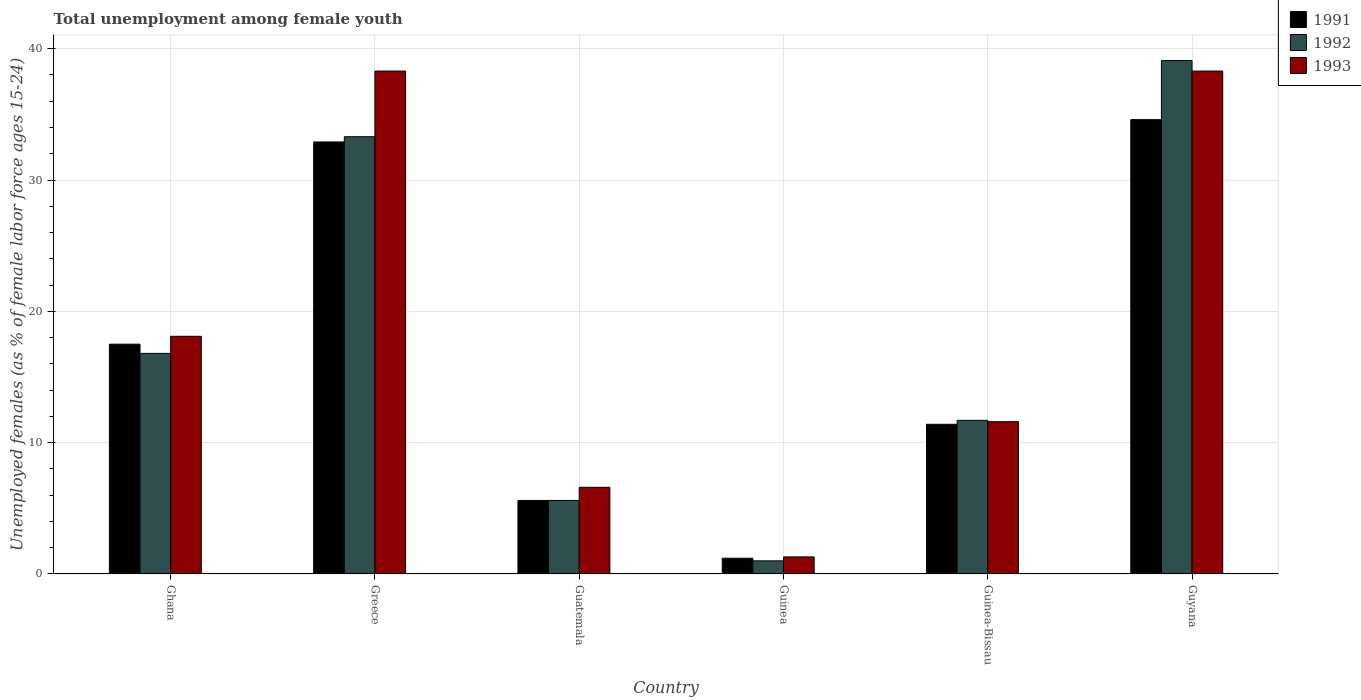How many different coloured bars are there?
Give a very brief answer. 3. Are the number of bars per tick equal to the number of legend labels?
Your answer should be compact. Yes. What is the label of the 4th group of bars from the left?
Offer a terse response. Guinea. In how many cases, is the number of bars for a given country not equal to the number of legend labels?
Give a very brief answer. 0. What is the percentage of unemployed females in in 1991 in Guatemala?
Give a very brief answer. 5.6. Across all countries, what is the maximum percentage of unemployed females in in 1992?
Make the answer very short. 39.1. In which country was the percentage of unemployed females in in 1991 maximum?
Your answer should be very brief. Guyana. In which country was the percentage of unemployed females in in 1992 minimum?
Your response must be concise. Guinea. What is the total percentage of unemployed females in in 1992 in the graph?
Your answer should be compact. 107.5. What is the difference between the percentage of unemployed females in in 1991 in Greece and that in Guatemala?
Offer a terse response. 27.3. What is the difference between the percentage of unemployed females in in 1993 in Guyana and the percentage of unemployed females in in 1992 in Guinea?
Your response must be concise. 37.3. What is the average percentage of unemployed females in in 1991 per country?
Ensure brevity in your answer.  17.2. What is the difference between the percentage of unemployed females in of/in 1991 and percentage of unemployed females in of/in 1992 in Greece?
Ensure brevity in your answer.  -0.4. In how many countries, is the percentage of unemployed females in in 1991 greater than 12 %?
Make the answer very short. 3. What is the ratio of the percentage of unemployed females in in 1992 in Greece to that in Guinea?
Your answer should be compact. 33.3. Is the percentage of unemployed females in in 1993 in Guinea less than that in Guinea-Bissau?
Keep it short and to the point. Yes. Is the difference between the percentage of unemployed females in in 1991 in Guatemala and Guyana greater than the difference between the percentage of unemployed females in in 1992 in Guatemala and Guyana?
Provide a short and direct response. Yes. What is the difference between the highest and the second highest percentage of unemployed females in in 1991?
Give a very brief answer. 15.4. What is the difference between the highest and the lowest percentage of unemployed females in in 1991?
Your answer should be compact. 33.4. In how many countries, is the percentage of unemployed females in in 1991 greater than the average percentage of unemployed females in in 1991 taken over all countries?
Make the answer very short. 3. Is it the case that in every country, the sum of the percentage of unemployed females in in 1993 and percentage of unemployed females in in 1991 is greater than the percentage of unemployed females in in 1992?
Offer a terse response. Yes. How many bars are there?
Offer a terse response. 18. Are all the bars in the graph horizontal?
Offer a very short reply. No. How many countries are there in the graph?
Ensure brevity in your answer.  6. Does the graph contain grids?
Make the answer very short. Yes. What is the title of the graph?
Ensure brevity in your answer.  Total unemployment among female youth. What is the label or title of the X-axis?
Keep it short and to the point. Country. What is the label or title of the Y-axis?
Offer a very short reply. Unemployed females (as % of female labor force ages 15-24). What is the Unemployed females (as % of female labor force ages 15-24) in 1991 in Ghana?
Your response must be concise. 17.5. What is the Unemployed females (as % of female labor force ages 15-24) of 1992 in Ghana?
Offer a very short reply. 16.8. What is the Unemployed females (as % of female labor force ages 15-24) of 1993 in Ghana?
Your answer should be very brief. 18.1. What is the Unemployed females (as % of female labor force ages 15-24) in 1991 in Greece?
Keep it short and to the point. 32.9. What is the Unemployed females (as % of female labor force ages 15-24) in 1992 in Greece?
Provide a succinct answer. 33.3. What is the Unemployed females (as % of female labor force ages 15-24) of 1993 in Greece?
Provide a succinct answer. 38.3. What is the Unemployed females (as % of female labor force ages 15-24) in 1991 in Guatemala?
Offer a terse response. 5.6. What is the Unemployed females (as % of female labor force ages 15-24) in 1992 in Guatemala?
Your answer should be very brief. 5.6. What is the Unemployed females (as % of female labor force ages 15-24) of 1993 in Guatemala?
Make the answer very short. 6.6. What is the Unemployed females (as % of female labor force ages 15-24) of 1991 in Guinea?
Offer a very short reply. 1.2. What is the Unemployed females (as % of female labor force ages 15-24) of 1993 in Guinea?
Provide a succinct answer. 1.3. What is the Unemployed females (as % of female labor force ages 15-24) in 1991 in Guinea-Bissau?
Offer a very short reply. 11.4. What is the Unemployed females (as % of female labor force ages 15-24) of 1992 in Guinea-Bissau?
Provide a short and direct response. 11.7. What is the Unemployed females (as % of female labor force ages 15-24) in 1993 in Guinea-Bissau?
Make the answer very short. 11.6. What is the Unemployed females (as % of female labor force ages 15-24) in 1991 in Guyana?
Make the answer very short. 34.6. What is the Unemployed females (as % of female labor force ages 15-24) of 1992 in Guyana?
Your answer should be compact. 39.1. What is the Unemployed females (as % of female labor force ages 15-24) of 1993 in Guyana?
Your answer should be very brief. 38.3. Across all countries, what is the maximum Unemployed females (as % of female labor force ages 15-24) in 1991?
Your answer should be very brief. 34.6. Across all countries, what is the maximum Unemployed females (as % of female labor force ages 15-24) in 1992?
Ensure brevity in your answer.  39.1. Across all countries, what is the maximum Unemployed females (as % of female labor force ages 15-24) of 1993?
Provide a short and direct response. 38.3. Across all countries, what is the minimum Unemployed females (as % of female labor force ages 15-24) in 1991?
Offer a very short reply. 1.2. Across all countries, what is the minimum Unemployed females (as % of female labor force ages 15-24) of 1992?
Provide a succinct answer. 1. Across all countries, what is the minimum Unemployed females (as % of female labor force ages 15-24) in 1993?
Make the answer very short. 1.3. What is the total Unemployed females (as % of female labor force ages 15-24) of 1991 in the graph?
Provide a short and direct response. 103.2. What is the total Unemployed females (as % of female labor force ages 15-24) in 1992 in the graph?
Your response must be concise. 107.5. What is the total Unemployed females (as % of female labor force ages 15-24) in 1993 in the graph?
Your response must be concise. 114.2. What is the difference between the Unemployed females (as % of female labor force ages 15-24) in 1991 in Ghana and that in Greece?
Make the answer very short. -15.4. What is the difference between the Unemployed females (as % of female labor force ages 15-24) of 1992 in Ghana and that in Greece?
Offer a very short reply. -16.5. What is the difference between the Unemployed females (as % of female labor force ages 15-24) in 1993 in Ghana and that in Greece?
Give a very brief answer. -20.2. What is the difference between the Unemployed females (as % of female labor force ages 15-24) of 1991 in Ghana and that in Guatemala?
Keep it short and to the point. 11.9. What is the difference between the Unemployed females (as % of female labor force ages 15-24) in 1992 in Ghana and that in Guatemala?
Offer a very short reply. 11.2. What is the difference between the Unemployed females (as % of female labor force ages 15-24) of 1991 in Ghana and that in Guyana?
Make the answer very short. -17.1. What is the difference between the Unemployed females (as % of female labor force ages 15-24) in 1992 in Ghana and that in Guyana?
Give a very brief answer. -22.3. What is the difference between the Unemployed females (as % of female labor force ages 15-24) in 1993 in Ghana and that in Guyana?
Provide a short and direct response. -20.2. What is the difference between the Unemployed females (as % of female labor force ages 15-24) in 1991 in Greece and that in Guatemala?
Provide a short and direct response. 27.3. What is the difference between the Unemployed females (as % of female labor force ages 15-24) in 1992 in Greece and that in Guatemala?
Your answer should be very brief. 27.7. What is the difference between the Unemployed females (as % of female labor force ages 15-24) of 1993 in Greece and that in Guatemala?
Provide a short and direct response. 31.7. What is the difference between the Unemployed females (as % of female labor force ages 15-24) in 1991 in Greece and that in Guinea?
Make the answer very short. 31.7. What is the difference between the Unemployed females (as % of female labor force ages 15-24) in 1992 in Greece and that in Guinea?
Your answer should be compact. 32.3. What is the difference between the Unemployed females (as % of female labor force ages 15-24) of 1991 in Greece and that in Guinea-Bissau?
Your answer should be very brief. 21.5. What is the difference between the Unemployed females (as % of female labor force ages 15-24) of 1992 in Greece and that in Guinea-Bissau?
Offer a very short reply. 21.6. What is the difference between the Unemployed females (as % of female labor force ages 15-24) in 1993 in Greece and that in Guinea-Bissau?
Offer a terse response. 26.7. What is the difference between the Unemployed females (as % of female labor force ages 15-24) in 1991 in Greece and that in Guyana?
Your answer should be compact. -1.7. What is the difference between the Unemployed females (as % of female labor force ages 15-24) in 1993 in Greece and that in Guyana?
Your response must be concise. 0. What is the difference between the Unemployed females (as % of female labor force ages 15-24) of 1992 in Guatemala and that in Guinea?
Provide a succinct answer. 4.6. What is the difference between the Unemployed females (as % of female labor force ages 15-24) of 1993 in Guatemala and that in Guinea?
Ensure brevity in your answer.  5.3. What is the difference between the Unemployed females (as % of female labor force ages 15-24) in 1992 in Guatemala and that in Guinea-Bissau?
Make the answer very short. -6.1. What is the difference between the Unemployed females (as % of female labor force ages 15-24) of 1993 in Guatemala and that in Guinea-Bissau?
Provide a short and direct response. -5. What is the difference between the Unemployed females (as % of female labor force ages 15-24) of 1992 in Guatemala and that in Guyana?
Ensure brevity in your answer.  -33.5. What is the difference between the Unemployed females (as % of female labor force ages 15-24) of 1993 in Guatemala and that in Guyana?
Ensure brevity in your answer.  -31.7. What is the difference between the Unemployed females (as % of female labor force ages 15-24) of 1992 in Guinea and that in Guinea-Bissau?
Your response must be concise. -10.7. What is the difference between the Unemployed females (as % of female labor force ages 15-24) in 1993 in Guinea and that in Guinea-Bissau?
Ensure brevity in your answer.  -10.3. What is the difference between the Unemployed females (as % of female labor force ages 15-24) of 1991 in Guinea and that in Guyana?
Offer a terse response. -33.4. What is the difference between the Unemployed females (as % of female labor force ages 15-24) of 1992 in Guinea and that in Guyana?
Offer a very short reply. -38.1. What is the difference between the Unemployed females (as % of female labor force ages 15-24) in 1993 in Guinea and that in Guyana?
Your answer should be very brief. -37. What is the difference between the Unemployed females (as % of female labor force ages 15-24) of 1991 in Guinea-Bissau and that in Guyana?
Keep it short and to the point. -23.2. What is the difference between the Unemployed females (as % of female labor force ages 15-24) of 1992 in Guinea-Bissau and that in Guyana?
Make the answer very short. -27.4. What is the difference between the Unemployed females (as % of female labor force ages 15-24) of 1993 in Guinea-Bissau and that in Guyana?
Offer a terse response. -26.7. What is the difference between the Unemployed females (as % of female labor force ages 15-24) of 1991 in Ghana and the Unemployed females (as % of female labor force ages 15-24) of 1992 in Greece?
Give a very brief answer. -15.8. What is the difference between the Unemployed females (as % of female labor force ages 15-24) in 1991 in Ghana and the Unemployed females (as % of female labor force ages 15-24) in 1993 in Greece?
Your response must be concise. -20.8. What is the difference between the Unemployed females (as % of female labor force ages 15-24) of 1992 in Ghana and the Unemployed females (as % of female labor force ages 15-24) of 1993 in Greece?
Your response must be concise. -21.5. What is the difference between the Unemployed females (as % of female labor force ages 15-24) in 1991 in Ghana and the Unemployed females (as % of female labor force ages 15-24) in 1992 in Guatemala?
Your response must be concise. 11.9. What is the difference between the Unemployed females (as % of female labor force ages 15-24) of 1992 in Ghana and the Unemployed females (as % of female labor force ages 15-24) of 1993 in Guinea?
Provide a succinct answer. 15.5. What is the difference between the Unemployed females (as % of female labor force ages 15-24) in 1991 in Ghana and the Unemployed females (as % of female labor force ages 15-24) in 1992 in Guinea-Bissau?
Your response must be concise. 5.8. What is the difference between the Unemployed females (as % of female labor force ages 15-24) in 1991 in Ghana and the Unemployed females (as % of female labor force ages 15-24) in 1993 in Guinea-Bissau?
Provide a short and direct response. 5.9. What is the difference between the Unemployed females (as % of female labor force ages 15-24) of 1992 in Ghana and the Unemployed females (as % of female labor force ages 15-24) of 1993 in Guinea-Bissau?
Provide a succinct answer. 5.2. What is the difference between the Unemployed females (as % of female labor force ages 15-24) in 1991 in Ghana and the Unemployed females (as % of female labor force ages 15-24) in 1992 in Guyana?
Ensure brevity in your answer.  -21.6. What is the difference between the Unemployed females (as % of female labor force ages 15-24) in 1991 in Ghana and the Unemployed females (as % of female labor force ages 15-24) in 1993 in Guyana?
Your answer should be compact. -20.8. What is the difference between the Unemployed females (as % of female labor force ages 15-24) of 1992 in Ghana and the Unemployed females (as % of female labor force ages 15-24) of 1993 in Guyana?
Your answer should be compact. -21.5. What is the difference between the Unemployed females (as % of female labor force ages 15-24) of 1991 in Greece and the Unemployed females (as % of female labor force ages 15-24) of 1992 in Guatemala?
Your answer should be compact. 27.3. What is the difference between the Unemployed females (as % of female labor force ages 15-24) of 1991 in Greece and the Unemployed females (as % of female labor force ages 15-24) of 1993 in Guatemala?
Your response must be concise. 26.3. What is the difference between the Unemployed females (as % of female labor force ages 15-24) of 1992 in Greece and the Unemployed females (as % of female labor force ages 15-24) of 1993 in Guatemala?
Your response must be concise. 26.7. What is the difference between the Unemployed females (as % of female labor force ages 15-24) of 1991 in Greece and the Unemployed females (as % of female labor force ages 15-24) of 1992 in Guinea?
Ensure brevity in your answer.  31.9. What is the difference between the Unemployed females (as % of female labor force ages 15-24) in 1991 in Greece and the Unemployed females (as % of female labor force ages 15-24) in 1993 in Guinea?
Provide a succinct answer. 31.6. What is the difference between the Unemployed females (as % of female labor force ages 15-24) in 1991 in Greece and the Unemployed females (as % of female labor force ages 15-24) in 1992 in Guinea-Bissau?
Offer a terse response. 21.2. What is the difference between the Unemployed females (as % of female labor force ages 15-24) of 1991 in Greece and the Unemployed females (as % of female labor force ages 15-24) of 1993 in Guinea-Bissau?
Offer a terse response. 21.3. What is the difference between the Unemployed females (as % of female labor force ages 15-24) in 1992 in Greece and the Unemployed females (as % of female labor force ages 15-24) in 1993 in Guinea-Bissau?
Keep it short and to the point. 21.7. What is the difference between the Unemployed females (as % of female labor force ages 15-24) in 1991 in Greece and the Unemployed females (as % of female labor force ages 15-24) in 1993 in Guyana?
Give a very brief answer. -5.4. What is the difference between the Unemployed females (as % of female labor force ages 15-24) in 1992 in Greece and the Unemployed females (as % of female labor force ages 15-24) in 1993 in Guyana?
Your answer should be compact. -5. What is the difference between the Unemployed females (as % of female labor force ages 15-24) of 1991 in Guatemala and the Unemployed females (as % of female labor force ages 15-24) of 1992 in Guinea?
Keep it short and to the point. 4.6. What is the difference between the Unemployed females (as % of female labor force ages 15-24) in 1991 in Guatemala and the Unemployed females (as % of female labor force ages 15-24) in 1992 in Guinea-Bissau?
Make the answer very short. -6.1. What is the difference between the Unemployed females (as % of female labor force ages 15-24) of 1991 in Guatemala and the Unemployed females (as % of female labor force ages 15-24) of 1993 in Guinea-Bissau?
Your answer should be very brief. -6. What is the difference between the Unemployed females (as % of female labor force ages 15-24) in 1991 in Guatemala and the Unemployed females (as % of female labor force ages 15-24) in 1992 in Guyana?
Ensure brevity in your answer.  -33.5. What is the difference between the Unemployed females (as % of female labor force ages 15-24) in 1991 in Guatemala and the Unemployed females (as % of female labor force ages 15-24) in 1993 in Guyana?
Ensure brevity in your answer.  -32.7. What is the difference between the Unemployed females (as % of female labor force ages 15-24) of 1992 in Guatemala and the Unemployed females (as % of female labor force ages 15-24) of 1993 in Guyana?
Ensure brevity in your answer.  -32.7. What is the difference between the Unemployed females (as % of female labor force ages 15-24) of 1991 in Guinea and the Unemployed females (as % of female labor force ages 15-24) of 1992 in Guinea-Bissau?
Your response must be concise. -10.5. What is the difference between the Unemployed females (as % of female labor force ages 15-24) of 1991 in Guinea and the Unemployed females (as % of female labor force ages 15-24) of 1992 in Guyana?
Give a very brief answer. -37.9. What is the difference between the Unemployed females (as % of female labor force ages 15-24) of 1991 in Guinea and the Unemployed females (as % of female labor force ages 15-24) of 1993 in Guyana?
Offer a very short reply. -37.1. What is the difference between the Unemployed females (as % of female labor force ages 15-24) of 1992 in Guinea and the Unemployed females (as % of female labor force ages 15-24) of 1993 in Guyana?
Your answer should be compact. -37.3. What is the difference between the Unemployed females (as % of female labor force ages 15-24) of 1991 in Guinea-Bissau and the Unemployed females (as % of female labor force ages 15-24) of 1992 in Guyana?
Make the answer very short. -27.7. What is the difference between the Unemployed females (as % of female labor force ages 15-24) of 1991 in Guinea-Bissau and the Unemployed females (as % of female labor force ages 15-24) of 1993 in Guyana?
Keep it short and to the point. -26.9. What is the difference between the Unemployed females (as % of female labor force ages 15-24) in 1992 in Guinea-Bissau and the Unemployed females (as % of female labor force ages 15-24) in 1993 in Guyana?
Make the answer very short. -26.6. What is the average Unemployed females (as % of female labor force ages 15-24) of 1991 per country?
Provide a succinct answer. 17.2. What is the average Unemployed females (as % of female labor force ages 15-24) in 1992 per country?
Make the answer very short. 17.92. What is the average Unemployed females (as % of female labor force ages 15-24) in 1993 per country?
Offer a very short reply. 19.03. What is the difference between the Unemployed females (as % of female labor force ages 15-24) in 1991 and Unemployed females (as % of female labor force ages 15-24) in 1992 in Greece?
Provide a succinct answer. -0.4. What is the difference between the Unemployed females (as % of female labor force ages 15-24) in 1991 and Unemployed females (as % of female labor force ages 15-24) in 1993 in Greece?
Ensure brevity in your answer.  -5.4. What is the difference between the Unemployed females (as % of female labor force ages 15-24) of 1991 and Unemployed females (as % of female labor force ages 15-24) of 1993 in Guatemala?
Make the answer very short. -1. What is the difference between the Unemployed females (as % of female labor force ages 15-24) of 1991 and Unemployed females (as % of female labor force ages 15-24) of 1993 in Guinea?
Offer a very short reply. -0.1. What is the difference between the Unemployed females (as % of female labor force ages 15-24) in 1992 and Unemployed females (as % of female labor force ages 15-24) in 1993 in Guinea?
Your response must be concise. -0.3. What is the difference between the Unemployed females (as % of female labor force ages 15-24) of 1991 and Unemployed females (as % of female labor force ages 15-24) of 1993 in Guinea-Bissau?
Your response must be concise. -0.2. What is the difference between the Unemployed females (as % of female labor force ages 15-24) in 1992 and Unemployed females (as % of female labor force ages 15-24) in 1993 in Guinea-Bissau?
Ensure brevity in your answer.  0.1. What is the difference between the Unemployed females (as % of female labor force ages 15-24) of 1991 and Unemployed females (as % of female labor force ages 15-24) of 1992 in Guyana?
Your answer should be very brief. -4.5. What is the difference between the Unemployed females (as % of female labor force ages 15-24) in 1992 and Unemployed females (as % of female labor force ages 15-24) in 1993 in Guyana?
Offer a very short reply. 0.8. What is the ratio of the Unemployed females (as % of female labor force ages 15-24) in 1991 in Ghana to that in Greece?
Ensure brevity in your answer.  0.53. What is the ratio of the Unemployed females (as % of female labor force ages 15-24) of 1992 in Ghana to that in Greece?
Your response must be concise. 0.5. What is the ratio of the Unemployed females (as % of female labor force ages 15-24) in 1993 in Ghana to that in Greece?
Your answer should be compact. 0.47. What is the ratio of the Unemployed females (as % of female labor force ages 15-24) in 1991 in Ghana to that in Guatemala?
Your answer should be very brief. 3.12. What is the ratio of the Unemployed females (as % of female labor force ages 15-24) of 1993 in Ghana to that in Guatemala?
Provide a short and direct response. 2.74. What is the ratio of the Unemployed females (as % of female labor force ages 15-24) in 1991 in Ghana to that in Guinea?
Your answer should be very brief. 14.58. What is the ratio of the Unemployed females (as % of female labor force ages 15-24) in 1992 in Ghana to that in Guinea?
Offer a very short reply. 16.8. What is the ratio of the Unemployed females (as % of female labor force ages 15-24) of 1993 in Ghana to that in Guinea?
Provide a short and direct response. 13.92. What is the ratio of the Unemployed females (as % of female labor force ages 15-24) of 1991 in Ghana to that in Guinea-Bissau?
Ensure brevity in your answer.  1.54. What is the ratio of the Unemployed females (as % of female labor force ages 15-24) in 1992 in Ghana to that in Guinea-Bissau?
Ensure brevity in your answer.  1.44. What is the ratio of the Unemployed females (as % of female labor force ages 15-24) in 1993 in Ghana to that in Guinea-Bissau?
Your response must be concise. 1.56. What is the ratio of the Unemployed females (as % of female labor force ages 15-24) in 1991 in Ghana to that in Guyana?
Ensure brevity in your answer.  0.51. What is the ratio of the Unemployed females (as % of female labor force ages 15-24) in 1992 in Ghana to that in Guyana?
Ensure brevity in your answer.  0.43. What is the ratio of the Unemployed females (as % of female labor force ages 15-24) of 1993 in Ghana to that in Guyana?
Offer a very short reply. 0.47. What is the ratio of the Unemployed females (as % of female labor force ages 15-24) of 1991 in Greece to that in Guatemala?
Keep it short and to the point. 5.88. What is the ratio of the Unemployed females (as % of female labor force ages 15-24) of 1992 in Greece to that in Guatemala?
Offer a terse response. 5.95. What is the ratio of the Unemployed females (as % of female labor force ages 15-24) of 1993 in Greece to that in Guatemala?
Your answer should be very brief. 5.8. What is the ratio of the Unemployed females (as % of female labor force ages 15-24) of 1991 in Greece to that in Guinea?
Provide a succinct answer. 27.42. What is the ratio of the Unemployed females (as % of female labor force ages 15-24) in 1992 in Greece to that in Guinea?
Your answer should be compact. 33.3. What is the ratio of the Unemployed females (as % of female labor force ages 15-24) in 1993 in Greece to that in Guinea?
Give a very brief answer. 29.46. What is the ratio of the Unemployed females (as % of female labor force ages 15-24) of 1991 in Greece to that in Guinea-Bissau?
Provide a succinct answer. 2.89. What is the ratio of the Unemployed females (as % of female labor force ages 15-24) in 1992 in Greece to that in Guinea-Bissau?
Keep it short and to the point. 2.85. What is the ratio of the Unemployed females (as % of female labor force ages 15-24) of 1993 in Greece to that in Guinea-Bissau?
Your answer should be very brief. 3.3. What is the ratio of the Unemployed females (as % of female labor force ages 15-24) in 1991 in Greece to that in Guyana?
Provide a short and direct response. 0.95. What is the ratio of the Unemployed females (as % of female labor force ages 15-24) of 1992 in Greece to that in Guyana?
Give a very brief answer. 0.85. What is the ratio of the Unemployed females (as % of female labor force ages 15-24) of 1993 in Greece to that in Guyana?
Keep it short and to the point. 1. What is the ratio of the Unemployed females (as % of female labor force ages 15-24) in 1991 in Guatemala to that in Guinea?
Keep it short and to the point. 4.67. What is the ratio of the Unemployed females (as % of female labor force ages 15-24) in 1993 in Guatemala to that in Guinea?
Offer a very short reply. 5.08. What is the ratio of the Unemployed females (as % of female labor force ages 15-24) in 1991 in Guatemala to that in Guinea-Bissau?
Your answer should be compact. 0.49. What is the ratio of the Unemployed females (as % of female labor force ages 15-24) of 1992 in Guatemala to that in Guinea-Bissau?
Make the answer very short. 0.48. What is the ratio of the Unemployed females (as % of female labor force ages 15-24) of 1993 in Guatemala to that in Guinea-Bissau?
Your answer should be very brief. 0.57. What is the ratio of the Unemployed females (as % of female labor force ages 15-24) in 1991 in Guatemala to that in Guyana?
Provide a succinct answer. 0.16. What is the ratio of the Unemployed females (as % of female labor force ages 15-24) in 1992 in Guatemala to that in Guyana?
Ensure brevity in your answer.  0.14. What is the ratio of the Unemployed females (as % of female labor force ages 15-24) of 1993 in Guatemala to that in Guyana?
Provide a succinct answer. 0.17. What is the ratio of the Unemployed females (as % of female labor force ages 15-24) of 1991 in Guinea to that in Guinea-Bissau?
Provide a short and direct response. 0.11. What is the ratio of the Unemployed females (as % of female labor force ages 15-24) in 1992 in Guinea to that in Guinea-Bissau?
Keep it short and to the point. 0.09. What is the ratio of the Unemployed females (as % of female labor force ages 15-24) of 1993 in Guinea to that in Guinea-Bissau?
Keep it short and to the point. 0.11. What is the ratio of the Unemployed females (as % of female labor force ages 15-24) of 1991 in Guinea to that in Guyana?
Give a very brief answer. 0.03. What is the ratio of the Unemployed females (as % of female labor force ages 15-24) of 1992 in Guinea to that in Guyana?
Make the answer very short. 0.03. What is the ratio of the Unemployed females (as % of female labor force ages 15-24) of 1993 in Guinea to that in Guyana?
Your answer should be compact. 0.03. What is the ratio of the Unemployed females (as % of female labor force ages 15-24) in 1991 in Guinea-Bissau to that in Guyana?
Your answer should be compact. 0.33. What is the ratio of the Unemployed females (as % of female labor force ages 15-24) in 1992 in Guinea-Bissau to that in Guyana?
Keep it short and to the point. 0.3. What is the ratio of the Unemployed females (as % of female labor force ages 15-24) in 1993 in Guinea-Bissau to that in Guyana?
Offer a terse response. 0.3. What is the difference between the highest and the lowest Unemployed females (as % of female labor force ages 15-24) of 1991?
Your answer should be very brief. 33.4. What is the difference between the highest and the lowest Unemployed females (as % of female labor force ages 15-24) in 1992?
Your answer should be very brief. 38.1. What is the difference between the highest and the lowest Unemployed females (as % of female labor force ages 15-24) in 1993?
Give a very brief answer. 37. 